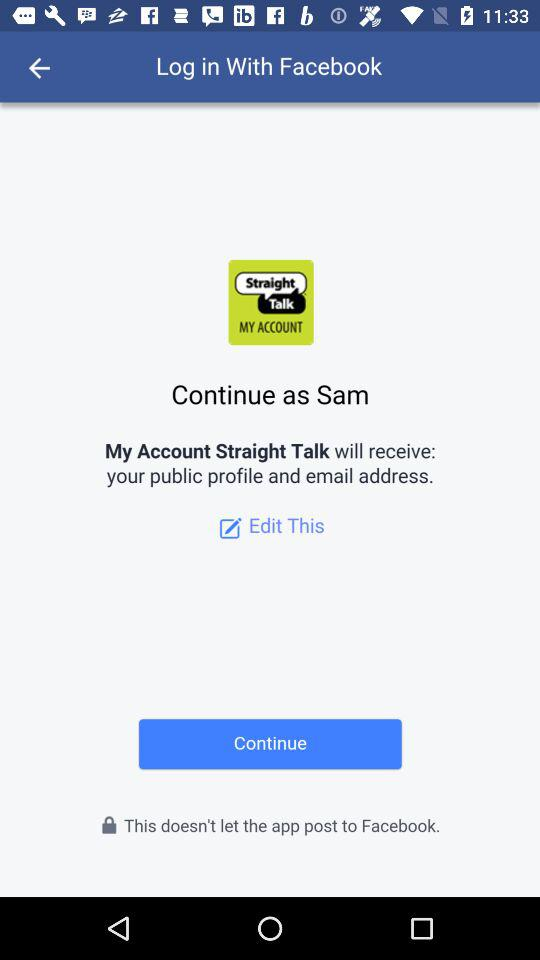What application is asking for permission? The application asking for permission is "My Account Straight Talk". 